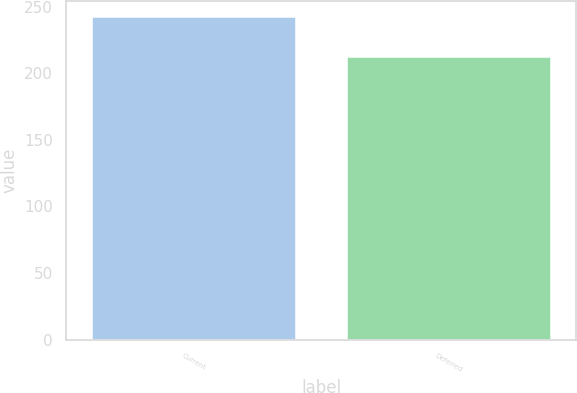Convert chart. <chart><loc_0><loc_0><loc_500><loc_500><bar_chart><fcel>Current<fcel>Deferred<nl><fcel>242.2<fcel>212.5<nl></chart> 